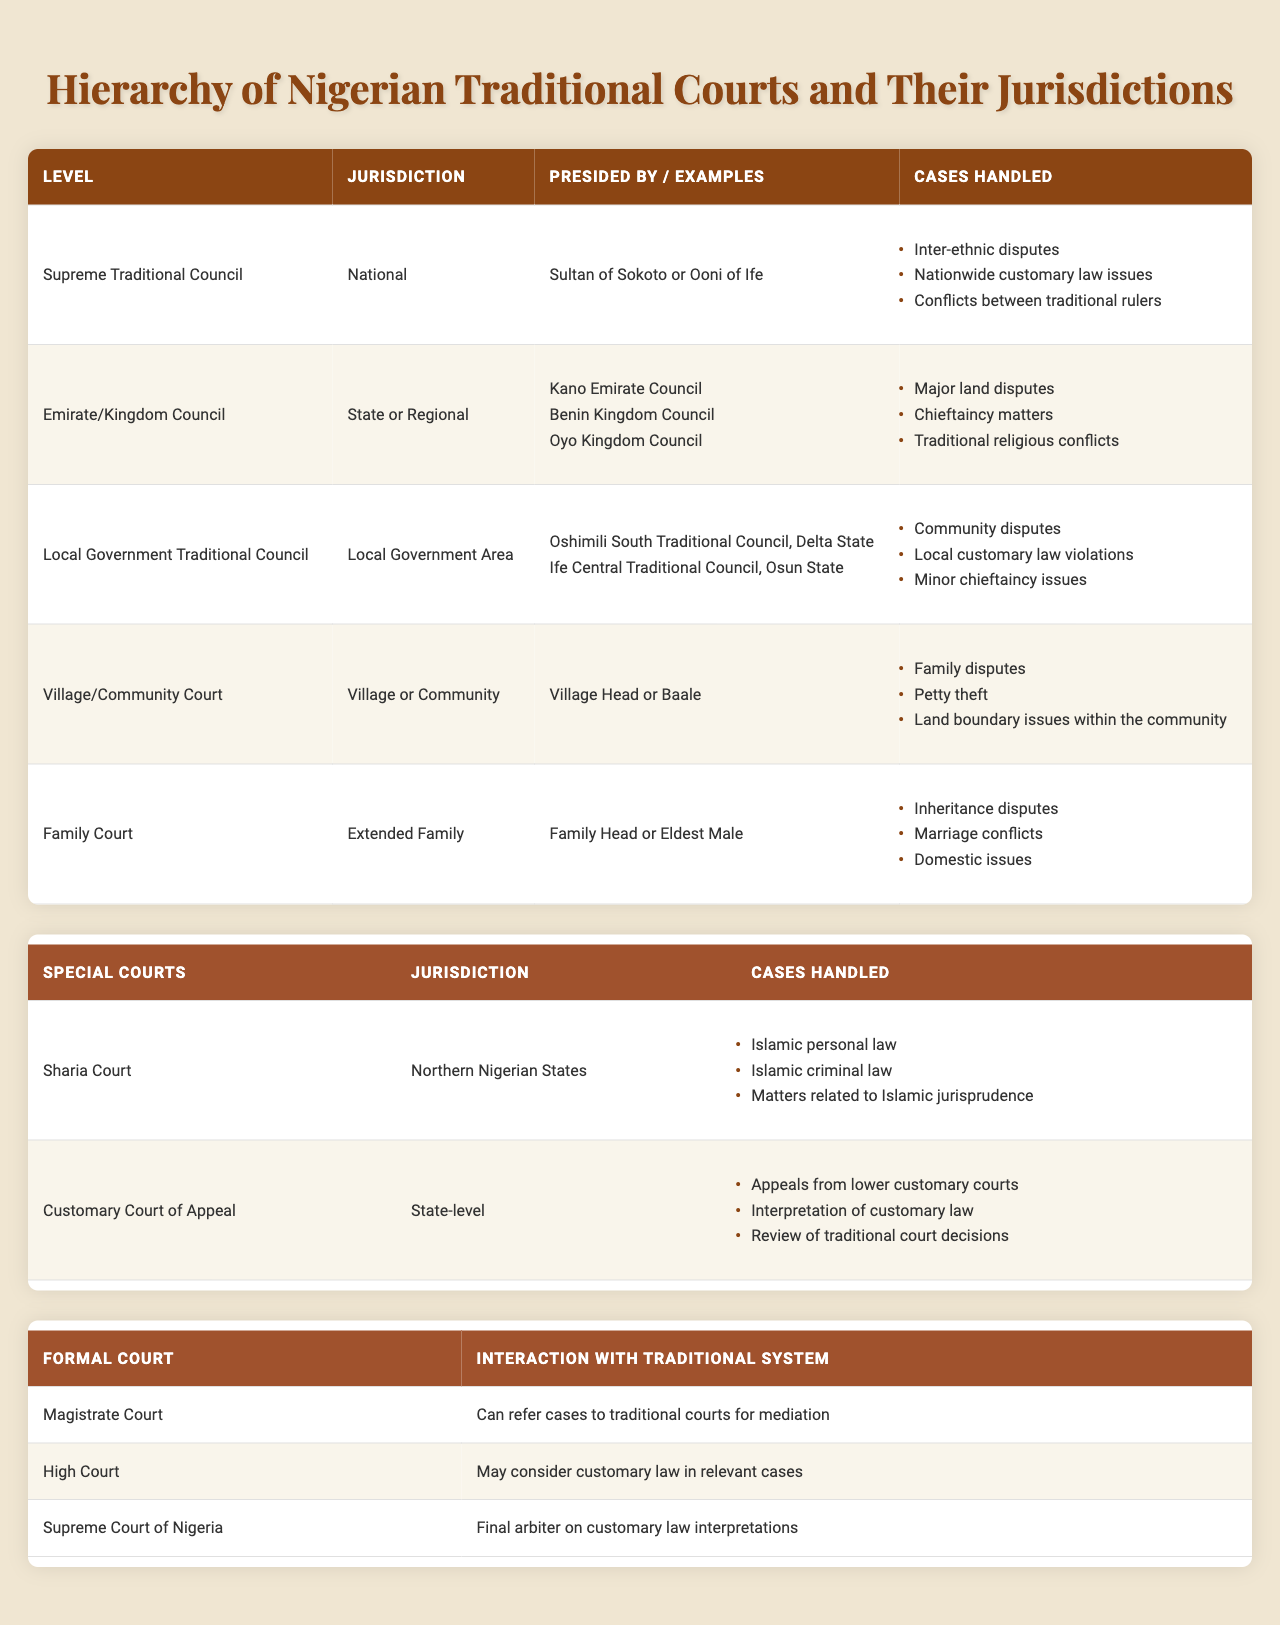What is the highest level in the traditional court system? The table lists the highest level as the "Supreme Traditional Council."
Answer: Supreme Traditional Council What type of cases does the Village/Community Court handle? The table specifies that the Village/Community Court deals with family disputes, petty theft, and land boundary issues within the community.
Answer: Family disputes, petty theft, land boundary issues What is the jurisdiction of the Emirate/Kingdom Council? According to the table, the Emirate/Kingdom Council has a jurisdiction at the state or regional level.
Answer: State or Regional Which court handles appeals from lower customary courts? The table indicates that the Customary Court of Appeal is responsible for handling appeals from lower customary courts.
Answer: Customary Court of Appeal Who presides over the Family Court? The table states that the Family Court is presided over by the Family Head or Eldest Male.
Answer: Family Head or Eldest Male How many types of special courts are listed in the table? The table shows that there are two types of special courts: Sharia Court and Customary Court of Appeal.
Answer: Two What kind of disputes can be settled by the Local Government Traditional Council? The table mentions that the Local Government Traditional Council deals with community disputes, local customary law violations, and minor chieftaincy issues.
Answer: Community disputes, local customary law violations, minor chieftaincy issues Is the Sharia Court limited to a specific region in Nigeria? The table confirms that the Sharia Court operates specifically in Northern Nigerian States.
Answer: Yes If a dispute arises regarding Islamic personal law, which court has jurisdiction? The table states that such matters fall under the jurisdiction of the Sharia Court.
Answer: Sharia Court Which traditional court level handles chieftaincy matters? The table indicates that chieftaincy matters are handled by the Emirate/Kingdom Council.
Answer: Emirate/Kingdom Council Are the local courts allowed to refer cases to traditional courts? The table states that Magistrate Courts can refer cases to traditional courts for mediation.
Answer: Yes What jurisdiction does the Family Court operate within? The table describes that the Family Court has jurisdiction over the extended family.
Answer: Extended Family How many cases is the Supreme Traditional Council noted for handling? The table lists three types of cases handled by the Supreme Traditional Council: inter-ethnic disputes, nationwide customary law issues, and conflicts between traditional rulers.
Answer: Three Which formal court may consider customary law in relevant cases? The table indicates that the High Court may consider customary law in relevant cases.
Answer: High Court What is the primary function of the Customary Court of Appeal? The table states that its primary function is to review appeals from lower customary courts and interpret customary law.
Answer: Review appeals and interpret customary law Which is the final arbiter on customary law interpretations? According to the table, the Supreme Court of Nigeria is the final arbiter on customary law interpretations.
Answer: Supreme Court of Nigeria 